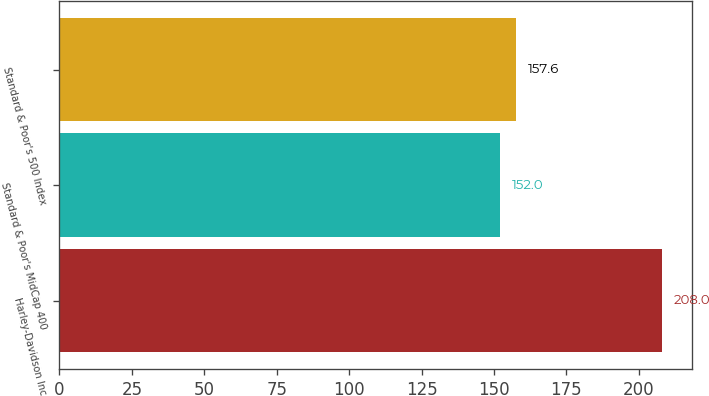Convert chart. <chart><loc_0><loc_0><loc_500><loc_500><bar_chart><fcel>Harley-Davidson Inc<fcel>Standard & Poor's MidCap 400<fcel>Standard & Poor's 500 Index<nl><fcel>208<fcel>152<fcel>157.6<nl></chart> 